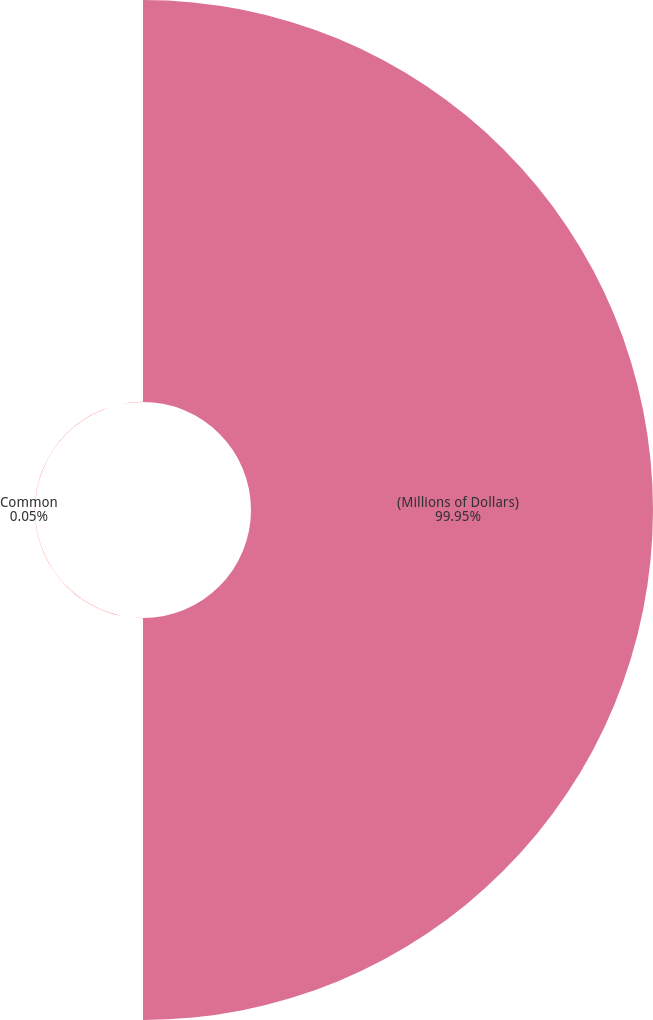<chart> <loc_0><loc_0><loc_500><loc_500><pie_chart><fcel>(Millions of Dollars)<fcel>Common<nl><fcel>99.95%<fcel>0.05%<nl></chart> 